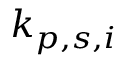Convert formula to latex. <formula><loc_0><loc_0><loc_500><loc_500>k _ { p , s , i }</formula> 